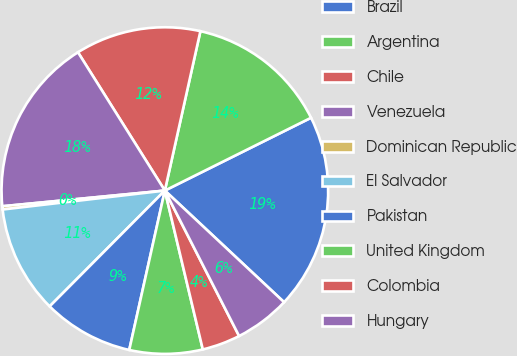<chart> <loc_0><loc_0><loc_500><loc_500><pie_chart><fcel>Brazil<fcel>Argentina<fcel>Chile<fcel>Venezuela<fcel>Dominican Republic<fcel>El Salvador<fcel>Pakistan<fcel>United Kingdom<fcel>Colombia<fcel>Hungary<nl><fcel>19.33%<fcel>14.15%<fcel>12.42%<fcel>17.6%<fcel>0.32%<fcel>10.69%<fcel>8.96%<fcel>7.23%<fcel>3.78%<fcel>5.51%<nl></chart> 